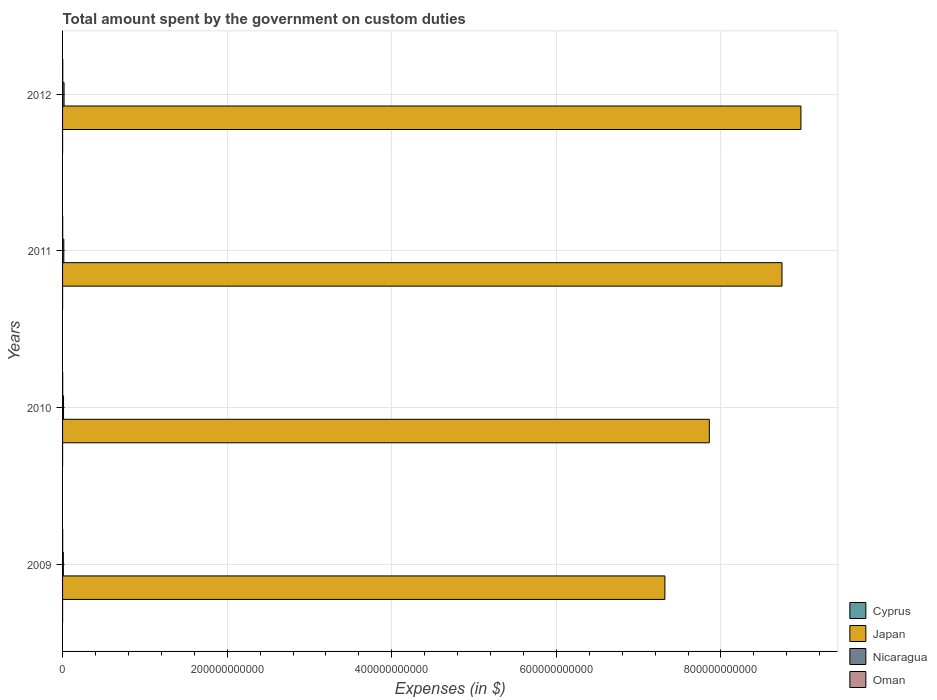How many groups of bars are there?
Provide a succinct answer. 4. Are the number of bars per tick equal to the number of legend labels?
Offer a very short reply. Yes. How many bars are there on the 1st tick from the bottom?
Provide a succinct answer. 4. What is the amount spent on custom duties by the government in Nicaragua in 2011?
Provide a short and direct response. 1.52e+09. Across all years, what is the maximum amount spent on custom duties by the government in Cyprus?
Your response must be concise. 3.98e+07. Across all years, what is the minimum amount spent on custom duties by the government in Cyprus?
Provide a succinct answer. 2.59e+07. In which year was the amount spent on custom duties by the government in Cyprus maximum?
Your answer should be compact. 2009. What is the total amount spent on custom duties by the government in Japan in the graph?
Provide a short and direct response. 3.29e+12. What is the difference between the amount spent on custom duties by the government in Cyprus in 2009 and that in 2010?
Provide a succinct answer. 3.40e+06. What is the difference between the amount spent on custom duties by the government in Oman in 2009 and the amount spent on custom duties by the government in Nicaragua in 2011?
Keep it short and to the point. -1.36e+09. What is the average amount spent on custom duties by the government in Cyprus per year?
Provide a short and direct response. 3.35e+07. In the year 2011, what is the difference between the amount spent on custom duties by the government in Nicaragua and amount spent on custom duties by the government in Japan?
Your answer should be very brief. -8.73e+11. What is the ratio of the amount spent on custom duties by the government in Nicaragua in 2011 to that in 2012?
Give a very brief answer. 0.84. Is the amount spent on custom duties by the government in Japan in 2009 less than that in 2012?
Offer a very short reply. Yes. What is the difference between the highest and the second highest amount spent on custom duties by the government in Nicaragua?
Give a very brief answer. 2.95e+08. What is the difference between the highest and the lowest amount spent on custom duties by the government in Nicaragua?
Make the answer very short. 8.46e+08. In how many years, is the amount spent on custom duties by the government in Japan greater than the average amount spent on custom duties by the government in Japan taken over all years?
Offer a very short reply. 2. Is it the case that in every year, the sum of the amount spent on custom duties by the government in Nicaragua and amount spent on custom duties by the government in Japan is greater than the sum of amount spent on custom duties by the government in Oman and amount spent on custom duties by the government in Cyprus?
Make the answer very short. No. What does the 1st bar from the top in 2009 represents?
Provide a succinct answer. Oman. What does the 1st bar from the bottom in 2011 represents?
Provide a short and direct response. Cyprus. Is it the case that in every year, the sum of the amount spent on custom duties by the government in Oman and amount spent on custom duties by the government in Japan is greater than the amount spent on custom duties by the government in Cyprus?
Ensure brevity in your answer.  Yes. How many bars are there?
Give a very brief answer. 16. How many years are there in the graph?
Provide a succinct answer. 4. What is the difference between two consecutive major ticks on the X-axis?
Make the answer very short. 2.00e+11. Does the graph contain any zero values?
Your response must be concise. No. Where does the legend appear in the graph?
Keep it short and to the point. Bottom right. What is the title of the graph?
Keep it short and to the point. Total amount spent by the government on custom duties. Does "East Asia (developing only)" appear as one of the legend labels in the graph?
Your answer should be very brief. No. What is the label or title of the X-axis?
Your answer should be very brief. Expenses (in $). What is the label or title of the Y-axis?
Make the answer very short. Years. What is the Expenses (in $) of Cyprus in 2009?
Keep it short and to the point. 3.98e+07. What is the Expenses (in $) of Japan in 2009?
Make the answer very short. 7.32e+11. What is the Expenses (in $) in Nicaragua in 2009?
Offer a very short reply. 9.70e+08. What is the Expenses (in $) of Oman in 2009?
Make the answer very short. 1.58e+08. What is the Expenses (in $) of Cyprus in 2010?
Your answer should be compact. 3.64e+07. What is the Expenses (in $) of Japan in 2010?
Your answer should be compact. 7.86e+11. What is the Expenses (in $) in Nicaragua in 2010?
Your response must be concise. 1.19e+09. What is the Expenses (in $) in Oman in 2010?
Give a very brief answer. 1.80e+08. What is the Expenses (in $) in Cyprus in 2011?
Provide a short and direct response. 3.19e+07. What is the Expenses (in $) in Japan in 2011?
Make the answer very short. 8.74e+11. What is the Expenses (in $) of Nicaragua in 2011?
Ensure brevity in your answer.  1.52e+09. What is the Expenses (in $) of Oman in 2011?
Your answer should be very brief. 1.61e+08. What is the Expenses (in $) in Cyprus in 2012?
Make the answer very short. 2.59e+07. What is the Expenses (in $) in Japan in 2012?
Offer a very short reply. 8.97e+11. What is the Expenses (in $) of Nicaragua in 2012?
Offer a very short reply. 1.82e+09. What is the Expenses (in $) of Oman in 2012?
Provide a short and direct response. 2.50e+08. Across all years, what is the maximum Expenses (in $) of Cyprus?
Ensure brevity in your answer.  3.98e+07. Across all years, what is the maximum Expenses (in $) of Japan?
Your response must be concise. 8.97e+11. Across all years, what is the maximum Expenses (in $) of Nicaragua?
Your answer should be compact. 1.82e+09. Across all years, what is the maximum Expenses (in $) of Oman?
Your response must be concise. 2.50e+08. Across all years, what is the minimum Expenses (in $) of Cyprus?
Your answer should be compact. 2.59e+07. Across all years, what is the minimum Expenses (in $) of Japan?
Provide a short and direct response. 7.32e+11. Across all years, what is the minimum Expenses (in $) in Nicaragua?
Give a very brief answer. 9.70e+08. Across all years, what is the minimum Expenses (in $) of Oman?
Your answer should be compact. 1.58e+08. What is the total Expenses (in $) of Cyprus in the graph?
Keep it short and to the point. 1.34e+08. What is the total Expenses (in $) of Japan in the graph?
Keep it short and to the point. 3.29e+12. What is the total Expenses (in $) in Nicaragua in the graph?
Provide a succinct answer. 5.50e+09. What is the total Expenses (in $) of Oman in the graph?
Give a very brief answer. 7.49e+08. What is the difference between the Expenses (in $) of Cyprus in 2009 and that in 2010?
Provide a short and direct response. 3.40e+06. What is the difference between the Expenses (in $) of Japan in 2009 and that in 2010?
Make the answer very short. -5.40e+1. What is the difference between the Expenses (in $) of Nicaragua in 2009 and that in 2010?
Your answer should be compact. -2.21e+08. What is the difference between the Expenses (in $) in Oman in 2009 and that in 2010?
Your answer should be compact. -2.15e+07. What is the difference between the Expenses (in $) in Cyprus in 2009 and that in 2011?
Keep it short and to the point. 7.90e+06. What is the difference between the Expenses (in $) of Japan in 2009 and that in 2011?
Ensure brevity in your answer.  -1.42e+11. What is the difference between the Expenses (in $) in Nicaragua in 2009 and that in 2011?
Keep it short and to the point. -5.52e+08. What is the difference between the Expenses (in $) in Oman in 2009 and that in 2011?
Offer a terse response. -3.10e+06. What is the difference between the Expenses (in $) in Cyprus in 2009 and that in 2012?
Make the answer very short. 1.39e+07. What is the difference between the Expenses (in $) of Japan in 2009 and that in 2012?
Keep it short and to the point. -1.65e+11. What is the difference between the Expenses (in $) in Nicaragua in 2009 and that in 2012?
Give a very brief answer. -8.46e+08. What is the difference between the Expenses (in $) of Oman in 2009 and that in 2012?
Your response must be concise. -9.20e+07. What is the difference between the Expenses (in $) of Cyprus in 2010 and that in 2011?
Make the answer very short. 4.50e+06. What is the difference between the Expenses (in $) in Japan in 2010 and that in 2011?
Offer a terse response. -8.83e+1. What is the difference between the Expenses (in $) of Nicaragua in 2010 and that in 2011?
Your answer should be very brief. -3.31e+08. What is the difference between the Expenses (in $) of Oman in 2010 and that in 2011?
Your answer should be compact. 1.84e+07. What is the difference between the Expenses (in $) of Cyprus in 2010 and that in 2012?
Make the answer very short. 1.05e+07. What is the difference between the Expenses (in $) of Japan in 2010 and that in 2012?
Ensure brevity in your answer.  -1.11e+11. What is the difference between the Expenses (in $) of Nicaragua in 2010 and that in 2012?
Ensure brevity in your answer.  -6.26e+08. What is the difference between the Expenses (in $) of Oman in 2010 and that in 2012?
Your response must be concise. -7.05e+07. What is the difference between the Expenses (in $) of Cyprus in 2011 and that in 2012?
Your answer should be compact. 6.00e+06. What is the difference between the Expenses (in $) of Japan in 2011 and that in 2012?
Make the answer very short. -2.30e+1. What is the difference between the Expenses (in $) of Nicaragua in 2011 and that in 2012?
Provide a short and direct response. -2.95e+08. What is the difference between the Expenses (in $) of Oman in 2011 and that in 2012?
Make the answer very short. -8.89e+07. What is the difference between the Expenses (in $) in Cyprus in 2009 and the Expenses (in $) in Japan in 2010?
Offer a very short reply. -7.86e+11. What is the difference between the Expenses (in $) of Cyprus in 2009 and the Expenses (in $) of Nicaragua in 2010?
Provide a short and direct response. -1.15e+09. What is the difference between the Expenses (in $) in Cyprus in 2009 and the Expenses (in $) in Oman in 2010?
Give a very brief answer. -1.40e+08. What is the difference between the Expenses (in $) in Japan in 2009 and the Expenses (in $) in Nicaragua in 2010?
Offer a very short reply. 7.31e+11. What is the difference between the Expenses (in $) in Japan in 2009 and the Expenses (in $) in Oman in 2010?
Your answer should be compact. 7.32e+11. What is the difference between the Expenses (in $) in Nicaragua in 2009 and the Expenses (in $) in Oman in 2010?
Your response must be concise. 7.91e+08. What is the difference between the Expenses (in $) in Cyprus in 2009 and the Expenses (in $) in Japan in 2011?
Give a very brief answer. -8.74e+11. What is the difference between the Expenses (in $) in Cyprus in 2009 and the Expenses (in $) in Nicaragua in 2011?
Make the answer very short. -1.48e+09. What is the difference between the Expenses (in $) in Cyprus in 2009 and the Expenses (in $) in Oman in 2011?
Your answer should be compact. -1.21e+08. What is the difference between the Expenses (in $) of Japan in 2009 and the Expenses (in $) of Nicaragua in 2011?
Ensure brevity in your answer.  7.30e+11. What is the difference between the Expenses (in $) of Japan in 2009 and the Expenses (in $) of Oman in 2011?
Your response must be concise. 7.32e+11. What is the difference between the Expenses (in $) in Nicaragua in 2009 and the Expenses (in $) in Oman in 2011?
Make the answer very short. 8.09e+08. What is the difference between the Expenses (in $) in Cyprus in 2009 and the Expenses (in $) in Japan in 2012?
Your response must be concise. -8.97e+11. What is the difference between the Expenses (in $) of Cyprus in 2009 and the Expenses (in $) of Nicaragua in 2012?
Offer a very short reply. -1.78e+09. What is the difference between the Expenses (in $) in Cyprus in 2009 and the Expenses (in $) in Oman in 2012?
Offer a terse response. -2.10e+08. What is the difference between the Expenses (in $) of Japan in 2009 and the Expenses (in $) of Nicaragua in 2012?
Provide a short and direct response. 7.30e+11. What is the difference between the Expenses (in $) of Japan in 2009 and the Expenses (in $) of Oman in 2012?
Give a very brief answer. 7.32e+11. What is the difference between the Expenses (in $) in Nicaragua in 2009 and the Expenses (in $) in Oman in 2012?
Your response must be concise. 7.20e+08. What is the difference between the Expenses (in $) of Cyprus in 2010 and the Expenses (in $) of Japan in 2011?
Provide a succinct answer. -8.74e+11. What is the difference between the Expenses (in $) of Cyprus in 2010 and the Expenses (in $) of Nicaragua in 2011?
Provide a succinct answer. -1.49e+09. What is the difference between the Expenses (in $) of Cyprus in 2010 and the Expenses (in $) of Oman in 2011?
Make the answer very short. -1.25e+08. What is the difference between the Expenses (in $) in Japan in 2010 and the Expenses (in $) in Nicaragua in 2011?
Your answer should be compact. 7.84e+11. What is the difference between the Expenses (in $) in Japan in 2010 and the Expenses (in $) in Oman in 2011?
Give a very brief answer. 7.86e+11. What is the difference between the Expenses (in $) in Nicaragua in 2010 and the Expenses (in $) in Oman in 2011?
Provide a short and direct response. 1.03e+09. What is the difference between the Expenses (in $) in Cyprus in 2010 and the Expenses (in $) in Japan in 2012?
Your answer should be compact. -8.97e+11. What is the difference between the Expenses (in $) in Cyprus in 2010 and the Expenses (in $) in Nicaragua in 2012?
Provide a succinct answer. -1.78e+09. What is the difference between the Expenses (in $) of Cyprus in 2010 and the Expenses (in $) of Oman in 2012?
Your answer should be very brief. -2.14e+08. What is the difference between the Expenses (in $) in Japan in 2010 and the Expenses (in $) in Nicaragua in 2012?
Offer a terse response. 7.84e+11. What is the difference between the Expenses (in $) in Japan in 2010 and the Expenses (in $) in Oman in 2012?
Offer a terse response. 7.86e+11. What is the difference between the Expenses (in $) in Nicaragua in 2010 and the Expenses (in $) in Oman in 2012?
Your answer should be compact. 9.41e+08. What is the difference between the Expenses (in $) of Cyprus in 2011 and the Expenses (in $) of Japan in 2012?
Provide a succinct answer. -8.97e+11. What is the difference between the Expenses (in $) in Cyprus in 2011 and the Expenses (in $) in Nicaragua in 2012?
Offer a terse response. -1.78e+09. What is the difference between the Expenses (in $) in Cyprus in 2011 and the Expenses (in $) in Oman in 2012?
Your answer should be compact. -2.18e+08. What is the difference between the Expenses (in $) in Japan in 2011 and the Expenses (in $) in Nicaragua in 2012?
Provide a short and direct response. 8.72e+11. What is the difference between the Expenses (in $) of Japan in 2011 and the Expenses (in $) of Oman in 2012?
Keep it short and to the point. 8.74e+11. What is the difference between the Expenses (in $) of Nicaragua in 2011 and the Expenses (in $) of Oman in 2012?
Give a very brief answer. 1.27e+09. What is the average Expenses (in $) of Cyprus per year?
Offer a terse response. 3.35e+07. What is the average Expenses (in $) of Japan per year?
Ensure brevity in your answer.  8.22e+11. What is the average Expenses (in $) in Nicaragua per year?
Offer a terse response. 1.37e+09. What is the average Expenses (in $) of Oman per year?
Provide a succinct answer. 1.87e+08. In the year 2009, what is the difference between the Expenses (in $) in Cyprus and Expenses (in $) in Japan?
Keep it short and to the point. -7.32e+11. In the year 2009, what is the difference between the Expenses (in $) of Cyprus and Expenses (in $) of Nicaragua?
Your answer should be compact. -9.30e+08. In the year 2009, what is the difference between the Expenses (in $) of Cyprus and Expenses (in $) of Oman?
Make the answer very short. -1.18e+08. In the year 2009, what is the difference between the Expenses (in $) of Japan and Expenses (in $) of Nicaragua?
Your response must be concise. 7.31e+11. In the year 2009, what is the difference between the Expenses (in $) in Japan and Expenses (in $) in Oman?
Your answer should be very brief. 7.32e+11. In the year 2009, what is the difference between the Expenses (in $) in Nicaragua and Expenses (in $) in Oman?
Provide a succinct answer. 8.12e+08. In the year 2010, what is the difference between the Expenses (in $) in Cyprus and Expenses (in $) in Japan?
Offer a very short reply. -7.86e+11. In the year 2010, what is the difference between the Expenses (in $) in Cyprus and Expenses (in $) in Nicaragua?
Your response must be concise. -1.15e+09. In the year 2010, what is the difference between the Expenses (in $) in Cyprus and Expenses (in $) in Oman?
Provide a succinct answer. -1.43e+08. In the year 2010, what is the difference between the Expenses (in $) in Japan and Expenses (in $) in Nicaragua?
Provide a succinct answer. 7.85e+11. In the year 2010, what is the difference between the Expenses (in $) in Japan and Expenses (in $) in Oman?
Offer a very short reply. 7.86e+11. In the year 2010, what is the difference between the Expenses (in $) of Nicaragua and Expenses (in $) of Oman?
Offer a very short reply. 1.01e+09. In the year 2011, what is the difference between the Expenses (in $) of Cyprus and Expenses (in $) of Japan?
Your answer should be compact. -8.74e+11. In the year 2011, what is the difference between the Expenses (in $) of Cyprus and Expenses (in $) of Nicaragua?
Your response must be concise. -1.49e+09. In the year 2011, what is the difference between the Expenses (in $) of Cyprus and Expenses (in $) of Oman?
Your answer should be very brief. -1.29e+08. In the year 2011, what is the difference between the Expenses (in $) of Japan and Expenses (in $) of Nicaragua?
Offer a terse response. 8.73e+11. In the year 2011, what is the difference between the Expenses (in $) in Japan and Expenses (in $) in Oman?
Your response must be concise. 8.74e+11. In the year 2011, what is the difference between the Expenses (in $) of Nicaragua and Expenses (in $) of Oman?
Provide a short and direct response. 1.36e+09. In the year 2012, what is the difference between the Expenses (in $) in Cyprus and Expenses (in $) in Japan?
Keep it short and to the point. -8.97e+11. In the year 2012, what is the difference between the Expenses (in $) of Cyprus and Expenses (in $) of Nicaragua?
Keep it short and to the point. -1.79e+09. In the year 2012, what is the difference between the Expenses (in $) of Cyprus and Expenses (in $) of Oman?
Give a very brief answer. -2.24e+08. In the year 2012, what is the difference between the Expenses (in $) of Japan and Expenses (in $) of Nicaragua?
Give a very brief answer. 8.95e+11. In the year 2012, what is the difference between the Expenses (in $) in Japan and Expenses (in $) in Oman?
Provide a short and direct response. 8.97e+11. In the year 2012, what is the difference between the Expenses (in $) of Nicaragua and Expenses (in $) of Oman?
Provide a short and direct response. 1.57e+09. What is the ratio of the Expenses (in $) of Cyprus in 2009 to that in 2010?
Provide a short and direct response. 1.09. What is the ratio of the Expenses (in $) in Japan in 2009 to that in 2010?
Provide a short and direct response. 0.93. What is the ratio of the Expenses (in $) in Nicaragua in 2009 to that in 2010?
Your answer should be compact. 0.81. What is the ratio of the Expenses (in $) in Oman in 2009 to that in 2010?
Offer a terse response. 0.88. What is the ratio of the Expenses (in $) of Cyprus in 2009 to that in 2011?
Ensure brevity in your answer.  1.25. What is the ratio of the Expenses (in $) of Japan in 2009 to that in 2011?
Give a very brief answer. 0.84. What is the ratio of the Expenses (in $) in Nicaragua in 2009 to that in 2011?
Keep it short and to the point. 0.64. What is the ratio of the Expenses (in $) in Oman in 2009 to that in 2011?
Offer a terse response. 0.98. What is the ratio of the Expenses (in $) in Cyprus in 2009 to that in 2012?
Your answer should be compact. 1.54. What is the ratio of the Expenses (in $) of Japan in 2009 to that in 2012?
Offer a very short reply. 0.82. What is the ratio of the Expenses (in $) of Nicaragua in 2009 to that in 2012?
Ensure brevity in your answer.  0.53. What is the ratio of the Expenses (in $) in Oman in 2009 to that in 2012?
Give a very brief answer. 0.63. What is the ratio of the Expenses (in $) of Cyprus in 2010 to that in 2011?
Provide a succinct answer. 1.14. What is the ratio of the Expenses (in $) in Japan in 2010 to that in 2011?
Your answer should be very brief. 0.9. What is the ratio of the Expenses (in $) in Nicaragua in 2010 to that in 2011?
Offer a very short reply. 0.78. What is the ratio of the Expenses (in $) in Oman in 2010 to that in 2011?
Make the answer very short. 1.11. What is the ratio of the Expenses (in $) of Cyprus in 2010 to that in 2012?
Provide a succinct answer. 1.41. What is the ratio of the Expenses (in $) of Japan in 2010 to that in 2012?
Offer a very short reply. 0.88. What is the ratio of the Expenses (in $) of Nicaragua in 2010 to that in 2012?
Provide a succinct answer. 0.66. What is the ratio of the Expenses (in $) in Oman in 2010 to that in 2012?
Give a very brief answer. 0.72. What is the ratio of the Expenses (in $) in Cyprus in 2011 to that in 2012?
Offer a very short reply. 1.23. What is the ratio of the Expenses (in $) of Japan in 2011 to that in 2012?
Provide a succinct answer. 0.97. What is the ratio of the Expenses (in $) in Nicaragua in 2011 to that in 2012?
Provide a succinct answer. 0.84. What is the ratio of the Expenses (in $) of Oman in 2011 to that in 2012?
Make the answer very short. 0.64. What is the difference between the highest and the second highest Expenses (in $) in Cyprus?
Offer a terse response. 3.40e+06. What is the difference between the highest and the second highest Expenses (in $) in Japan?
Your answer should be compact. 2.30e+1. What is the difference between the highest and the second highest Expenses (in $) in Nicaragua?
Ensure brevity in your answer.  2.95e+08. What is the difference between the highest and the second highest Expenses (in $) of Oman?
Keep it short and to the point. 7.05e+07. What is the difference between the highest and the lowest Expenses (in $) in Cyprus?
Keep it short and to the point. 1.39e+07. What is the difference between the highest and the lowest Expenses (in $) of Japan?
Give a very brief answer. 1.65e+11. What is the difference between the highest and the lowest Expenses (in $) of Nicaragua?
Provide a short and direct response. 8.46e+08. What is the difference between the highest and the lowest Expenses (in $) in Oman?
Give a very brief answer. 9.20e+07. 